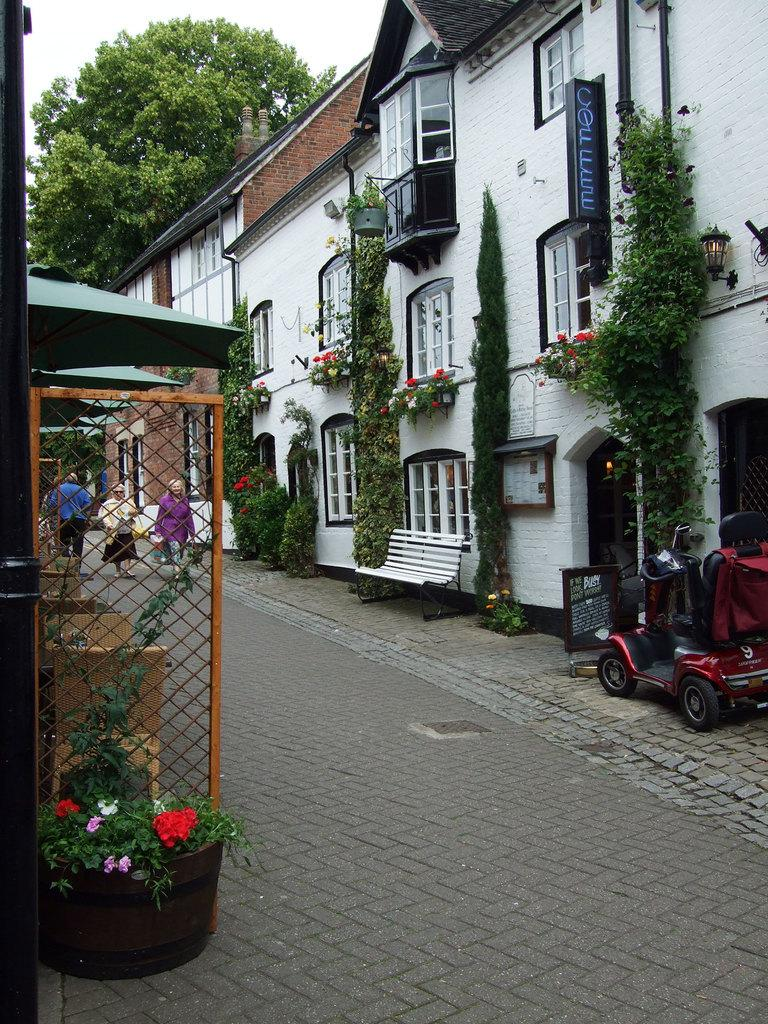What is located in front of the house in the image? There are many plants in front of the house in the image. What can be seen on the left side of the image? There are people on the left side of the image. What are the people doing in the image? The people are walking. Where is the hydrant located in the image? There is no hydrant present in the image. Can you tell me how many tickets the woman is holding in the image? There is no woman or tickets present in the image. 